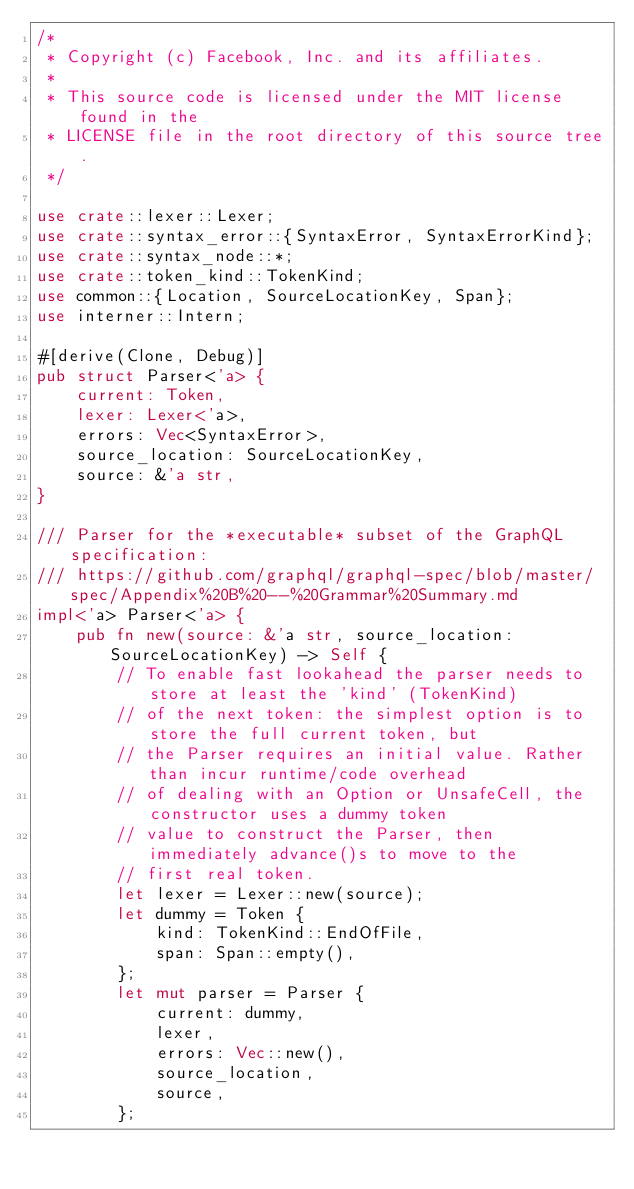Convert code to text. <code><loc_0><loc_0><loc_500><loc_500><_Rust_>/*
 * Copyright (c) Facebook, Inc. and its affiliates.
 *
 * This source code is licensed under the MIT license found in the
 * LICENSE file in the root directory of this source tree.
 */

use crate::lexer::Lexer;
use crate::syntax_error::{SyntaxError, SyntaxErrorKind};
use crate::syntax_node::*;
use crate::token_kind::TokenKind;
use common::{Location, SourceLocationKey, Span};
use interner::Intern;

#[derive(Clone, Debug)]
pub struct Parser<'a> {
    current: Token,
    lexer: Lexer<'a>,
    errors: Vec<SyntaxError>,
    source_location: SourceLocationKey,
    source: &'a str,
}

/// Parser for the *executable* subset of the GraphQL specification:
/// https://github.com/graphql/graphql-spec/blob/master/spec/Appendix%20B%20--%20Grammar%20Summary.md
impl<'a> Parser<'a> {
    pub fn new(source: &'a str, source_location: SourceLocationKey) -> Self {
        // To enable fast lookahead the parser needs to store at least the 'kind' (TokenKind)
        // of the next token: the simplest option is to store the full current token, but
        // the Parser requires an initial value. Rather than incur runtime/code overhead
        // of dealing with an Option or UnsafeCell, the constructor uses a dummy token
        // value to construct the Parser, then immediately advance()s to move to the
        // first real token.
        let lexer = Lexer::new(source);
        let dummy = Token {
            kind: TokenKind::EndOfFile,
            span: Span::empty(),
        };
        let mut parser = Parser {
            current: dummy,
            lexer,
            errors: Vec::new(),
            source_location,
            source,
        };</code> 